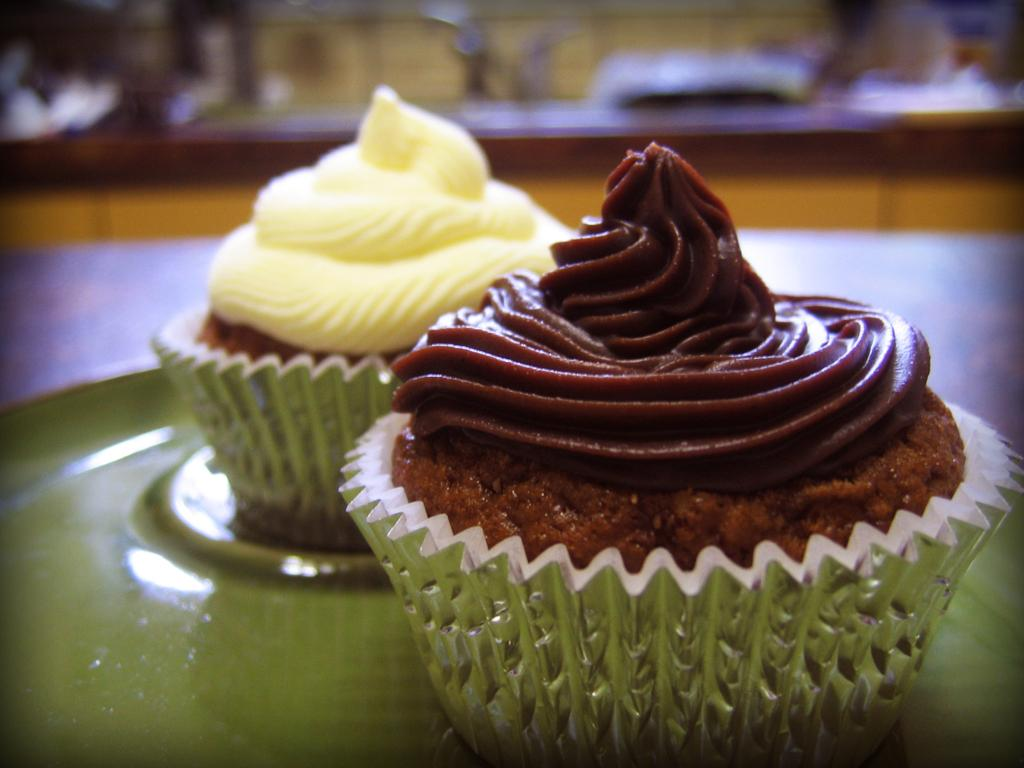What type of food can be seen in the image? There are cupcakes in the image. Can you describe the background of the image? The background of the image is blurry. What type of debt is being discussed in the image? There is no mention of debt in the image; it features cupcakes and a blurry background. What type of tin can be seen in the image? There is no tin present in the image. 